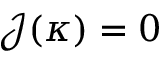Convert formula to latex. <formula><loc_0><loc_0><loc_500><loc_500>\mathcal { J } ( \kappa ) = 0</formula> 